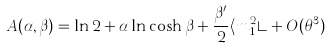Convert formula to latex. <formula><loc_0><loc_0><loc_500><loc_500>A ( \alpha , \beta ) = \ln 2 + \alpha \ln \cosh \beta + \frac { \beta ^ { \prime } } { 2 } \langle m _ { 1 } ^ { 2 } \rangle + O ( \theta ^ { 3 } )</formula> 